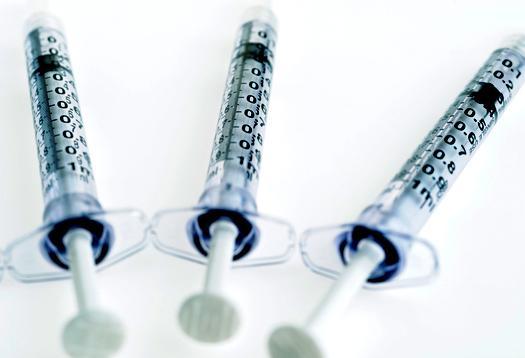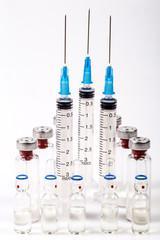The first image is the image on the left, the second image is the image on the right. For the images shown, is this caption "An image includes syringes with green, red, and blue components." true? Answer yes or no. No. The first image is the image on the left, the second image is the image on the right. For the images displayed, is the sentence "Three syringes lie on a surface near each other in the image on the left." factually correct? Answer yes or no. Yes. 